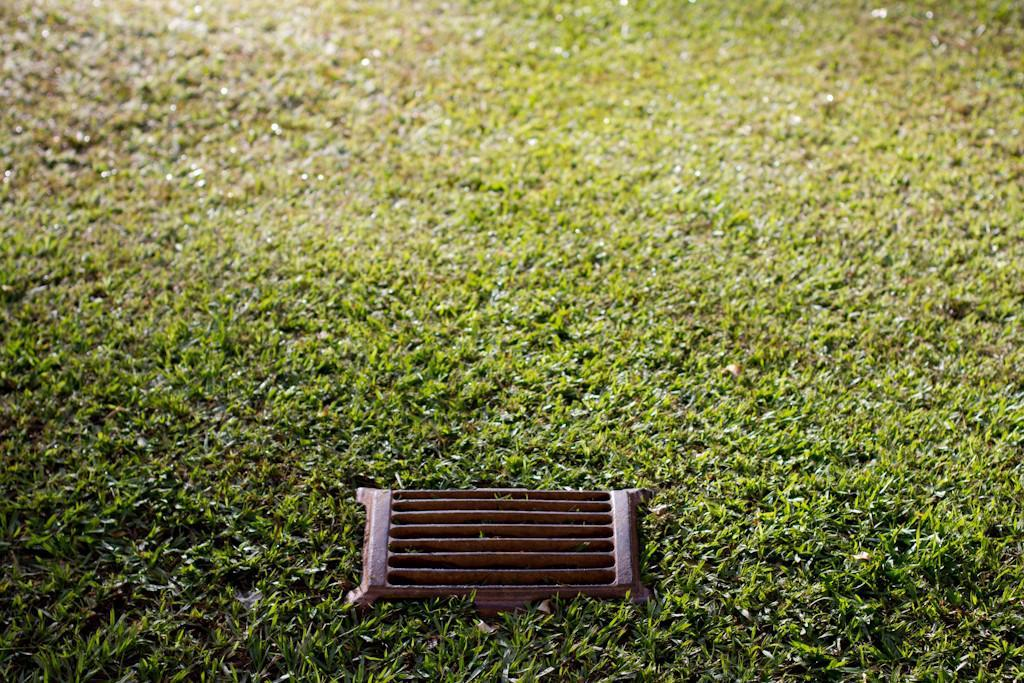What is the main object in the image? There is a grill in the image. Where is the grill located? The grill is on the grass. How much money is on the grill in the image? There is no money present on the grill in the image. What is the daughter doing in the image? There is no daughter present in the image. 